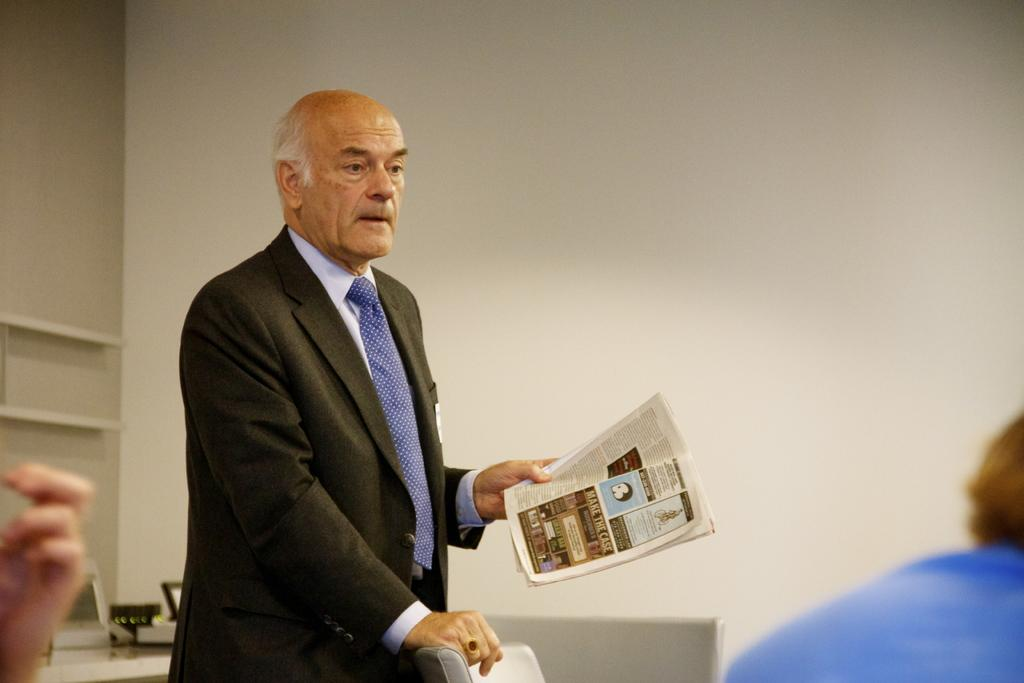What is the person in the image holding? The person is holding a book. What type of clothing is the person wearing? The person is wearing a suit. Can you describe the furniture in the image? There is a chair in the image. How many people are present in the image? There are people in the image. What is visible in the background of the image? There is a wall in the image. What objects can be seen on a table in the image? There are things on a table in the image. What type of whip is being used to create humor in the image? There is no whip or humor present in the image; it features a person holding a book and wearing a suit, with other people and objects in the background. 